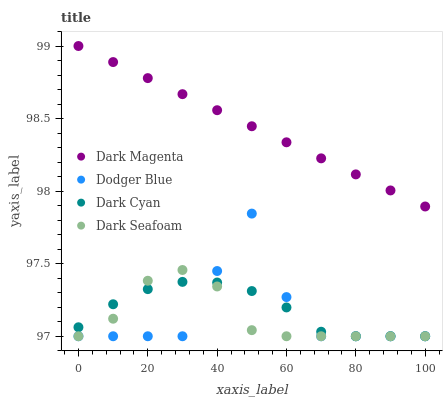Does Dark Seafoam have the minimum area under the curve?
Answer yes or no. Yes. Does Dark Magenta have the maximum area under the curve?
Answer yes or no. Yes. Does Dodger Blue have the minimum area under the curve?
Answer yes or no. No. Does Dodger Blue have the maximum area under the curve?
Answer yes or no. No. Is Dark Magenta the smoothest?
Answer yes or no. Yes. Is Dodger Blue the roughest?
Answer yes or no. Yes. Is Dark Seafoam the smoothest?
Answer yes or no. No. Is Dark Seafoam the roughest?
Answer yes or no. No. Does Dark Cyan have the lowest value?
Answer yes or no. Yes. Does Dark Magenta have the lowest value?
Answer yes or no. No. Does Dark Magenta have the highest value?
Answer yes or no. Yes. Does Dark Seafoam have the highest value?
Answer yes or no. No. Is Dark Seafoam less than Dark Magenta?
Answer yes or no. Yes. Is Dark Magenta greater than Dodger Blue?
Answer yes or no. Yes. Does Dark Seafoam intersect Dark Cyan?
Answer yes or no. Yes. Is Dark Seafoam less than Dark Cyan?
Answer yes or no. No. Is Dark Seafoam greater than Dark Cyan?
Answer yes or no. No. Does Dark Seafoam intersect Dark Magenta?
Answer yes or no. No. 